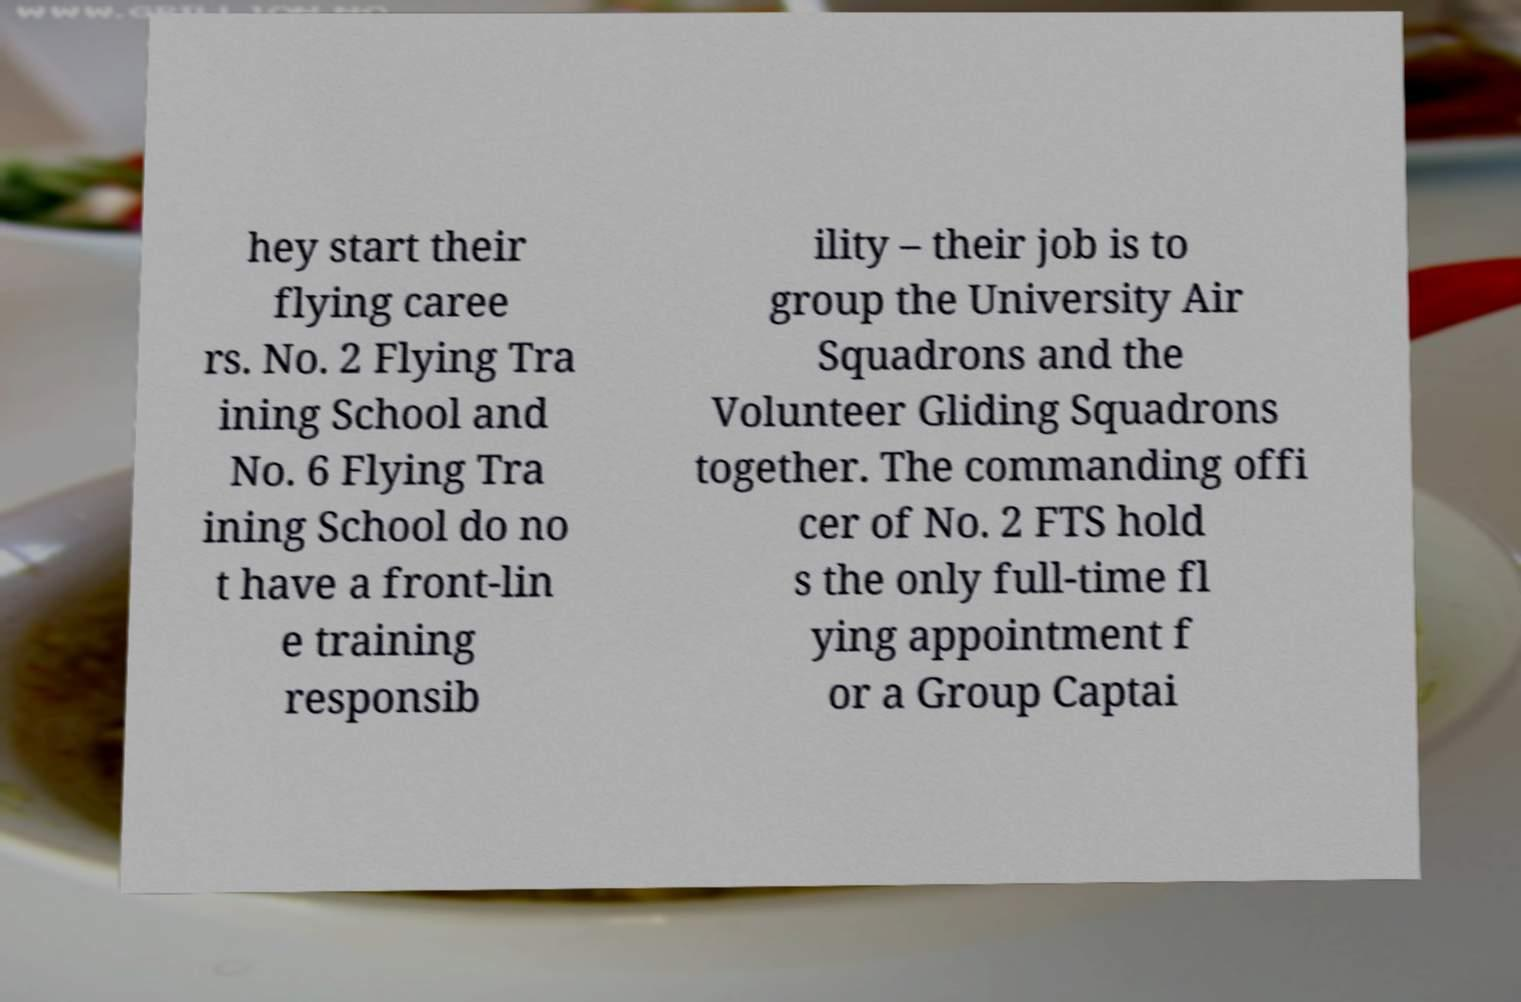There's text embedded in this image that I need extracted. Can you transcribe it verbatim? hey start their flying caree rs. No. 2 Flying Tra ining School and No. 6 Flying Tra ining School do no t have a front-lin e training responsib ility – their job is to group the University Air Squadrons and the Volunteer Gliding Squadrons together. The commanding offi cer of No. 2 FTS hold s the only full-time fl ying appointment f or a Group Captai 